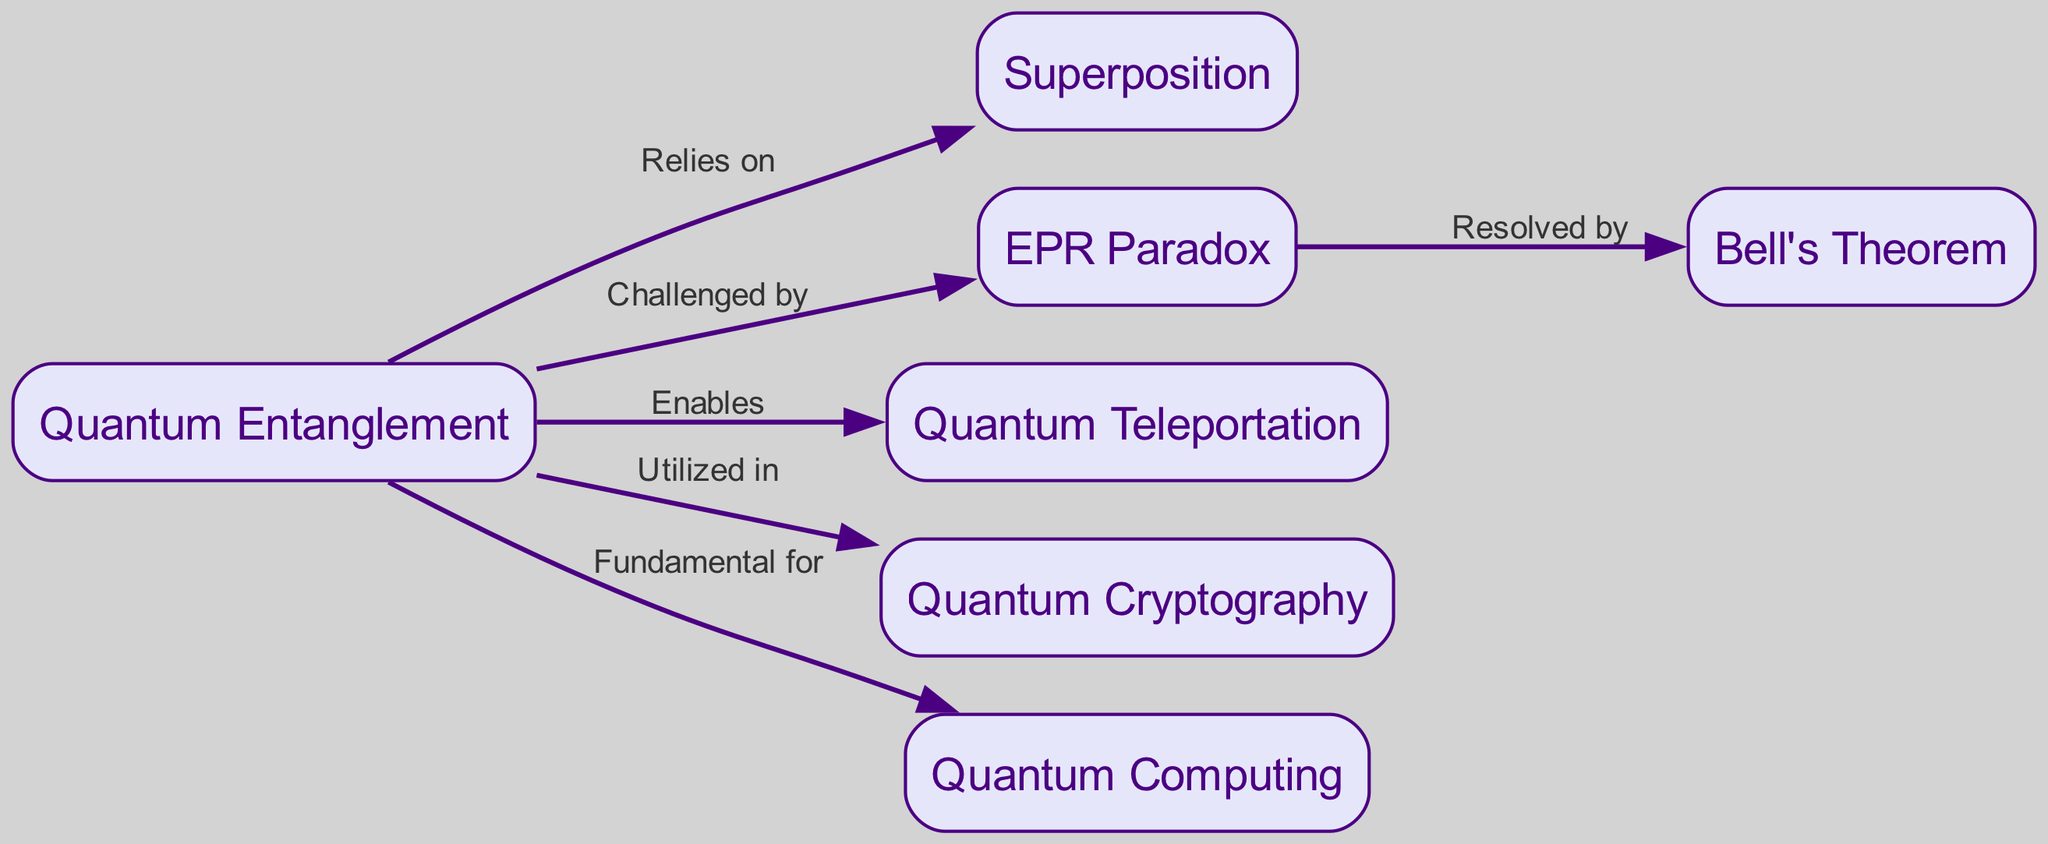What is the total number of nodes in the diagram? The diagram lists the following nodes: Quantum Entanglement, Superposition, EPR Paradox, Quantum Teleportation, Quantum Cryptography, Bell's Theorem, and Quantum Computing. Counting these gives a total of seven nodes.
Answer: 7 Which concept directly challenges quantum entanglement? The edge labeled "Challenged by" points directly to the node EPR Paradox, indicating that it is the concept that directly challenges quantum entanglement.
Answer: EPR Paradox How many edges originate from the quantum entanglement node? The quantum entanglement node has five outgoing edges connecting it to Superposition, EPR Paradox, Quantum Teleportation, Quantum Cryptography, and Quantum Computing. Therefore, the count of edges originating from this node is five.
Answer: 5 What is resolved by Bell's Theorem? The diagram states that the EPR Paradox is "Resolved by" Bell's Theorem, indicating that Bell’s Theorem addresses or resolves the issues raised by the EPR Paradox.
Answer: EPR Paradox What relationship does quantum entanglement have with quantum computing? The arrow labeled "Fundamental for" connects quantum entanglement to quantum computing, signifying that quantum entanglement is a foundational aspect of quantum computing.
Answer: Fundamental for Which concept is utilized in quantum cryptography? The diagram indicates that quantum entanglement is "Utilized in" quantum cryptography, showing the dependency or application of quantum entanglement within quantum cryptographic techniques.
Answer: Quantum Entanglement What does quantum teleportation enable? The edge labeled "Enables" leads from quantum entanglement to quantum teleportation, indicating that quantum entanglement is necessary for achieving quantum teleportation processes.
Answer: Quantum Teleportation How does the EPR Paradox relate to Bell's Theorem? The edge connecting EPR Paradox to Bell's Theorem is labeled "Resolved by," indicating that Bell's Theorem provides a resolution or explanation of the EPR Paradox's concerns regarding quantum mechanics.
Answer: Resolved by 